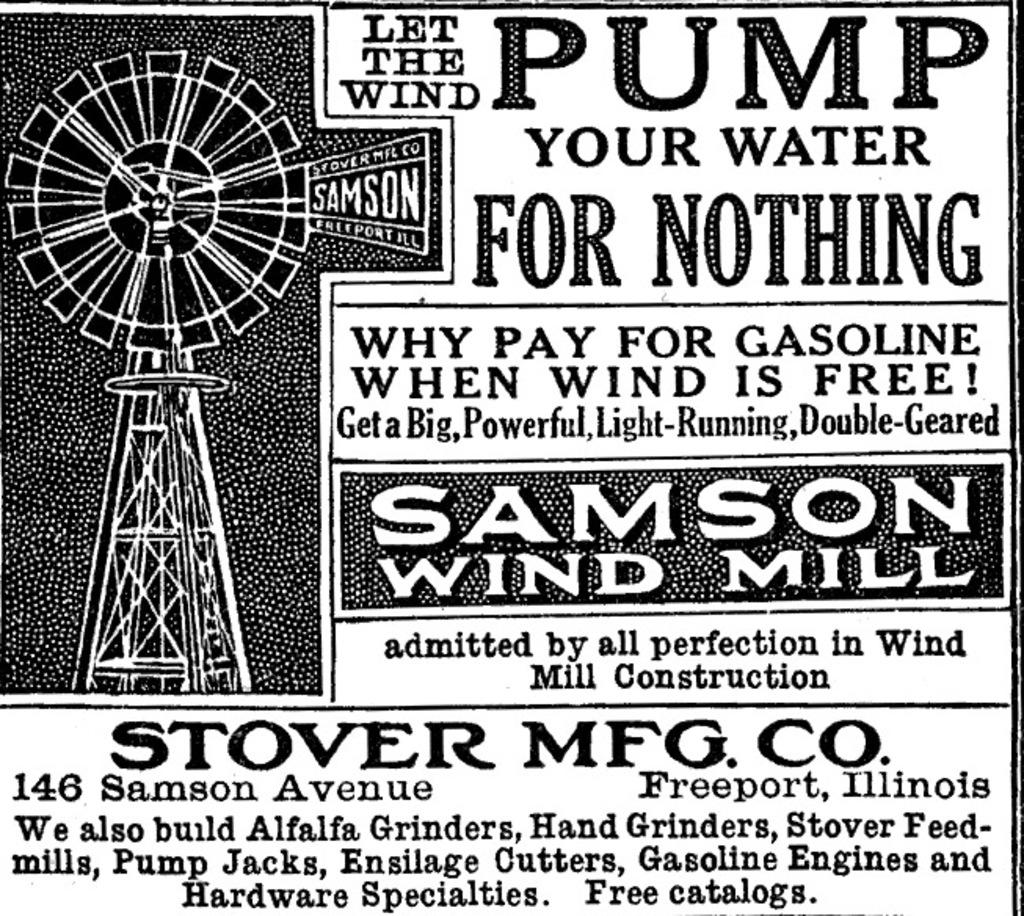What town is stover located in?
Your answer should be very brief. Freeport. What is the address for stover mfg co?
Offer a very short reply. 146 samson avenue freeport, illinois. 